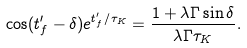<formula> <loc_0><loc_0><loc_500><loc_500>\cos ( t ^ { \prime } _ { f } - \delta ) e ^ { t ^ { \prime } _ { f } / \tau _ { K } } = \frac { 1 + \lambda \Gamma \sin \delta } { \lambda \Gamma \tau _ { K } } .</formula> 